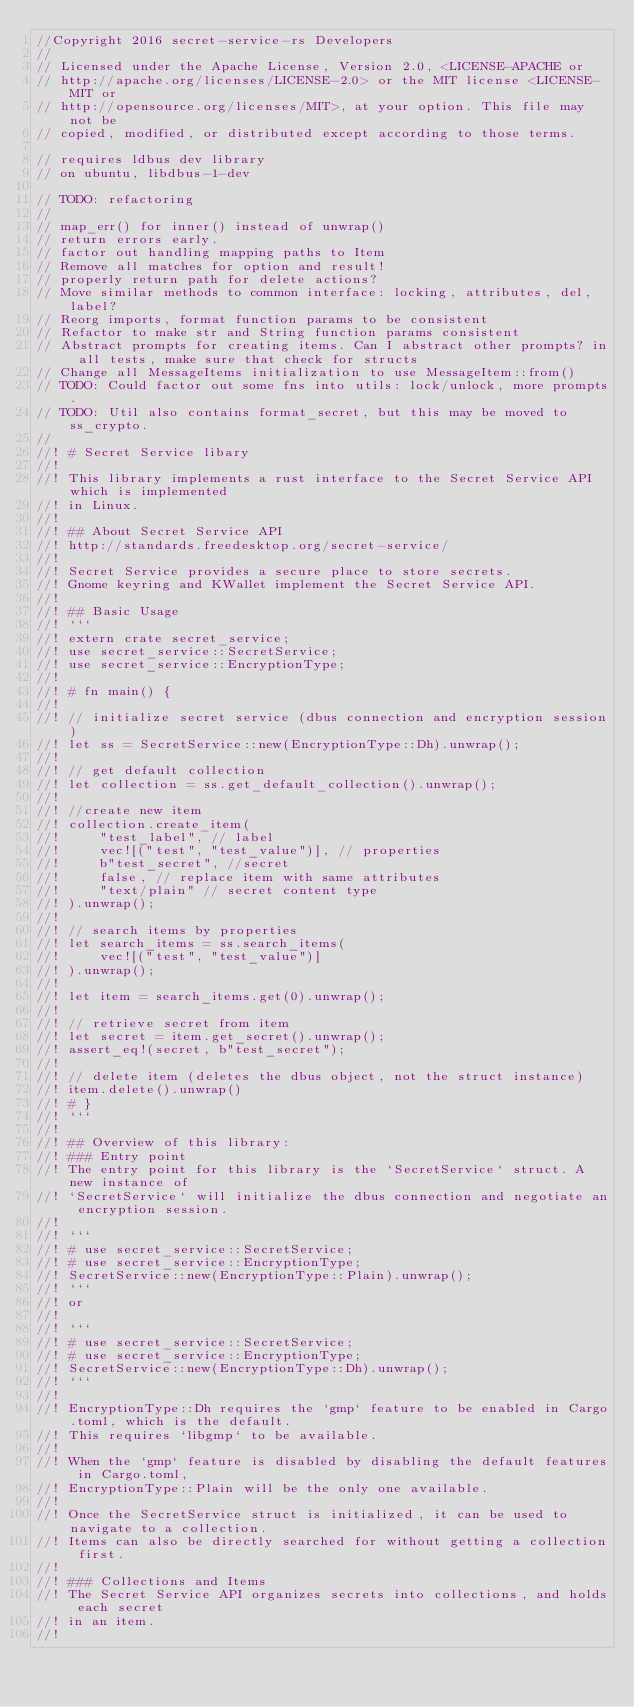Convert code to text. <code><loc_0><loc_0><loc_500><loc_500><_Rust_>//Copyright 2016 secret-service-rs Developers
//
// Licensed under the Apache License, Version 2.0, <LICENSE-APACHE or
// http://apache.org/licenses/LICENSE-2.0> or the MIT license <LICENSE-MIT or
// http://opensource.org/licenses/MIT>, at your option. This file may not be
// copied, modified, or distributed except according to those terms.

// requires ldbus dev library
// on ubuntu, libdbus-1-dev

// TODO: refactoring
//
// map_err() for inner() instead of unwrap()
// return errors early.
// factor out handling mapping paths to Item
// Remove all matches for option and result!
// properly return path for delete actions?
// Move similar methods to common interface: locking, attributes, del, label?
// Reorg imports, format function params to be consistent
// Refactor to make str and String function params consistent
// Abstract prompts for creating items. Can I abstract other prompts? in all tests, make sure that check for structs
// Change all MessageItems initialization to use MessageItem::from()
// TODO: Could factor out some fns into utils: lock/unlock, more prompts.
// TODO: Util also contains format_secret, but this may be moved to ss_crypto.
//
//! # Secret Service libary
//!
//! This library implements a rust interface to the Secret Service API which is implemented
//! in Linux.
//!
//! ## About Secret Service API
//! http://standards.freedesktop.org/secret-service/
//!
//! Secret Service provides a secure place to store secrets.
//! Gnome keyring and KWallet implement the Secret Service API.
//!
//! ## Basic Usage
//! ```
//! extern crate secret_service;
//! use secret_service::SecretService;
//! use secret_service::EncryptionType;
//!
//! # fn main() {
//!
//! // initialize secret service (dbus connection and encryption session)
//! let ss = SecretService::new(EncryptionType::Dh).unwrap();
//!
//! // get default collection
//! let collection = ss.get_default_collection().unwrap();
//!
//! //create new item
//! collection.create_item(
//!     "test_label", // label
//!     vec![("test", "test_value")], // properties
//!     b"test_secret", //secret
//!     false, // replace item with same attributes
//!     "text/plain" // secret content type
//! ).unwrap();
//!
//! // search items by properties
//! let search_items = ss.search_items(
//!     vec![("test", "test_value")]
//! ).unwrap();
//!
//! let item = search_items.get(0).unwrap();
//!
//! // retrieve secret from item
//! let secret = item.get_secret().unwrap();
//! assert_eq!(secret, b"test_secret");
//!
//! // delete item (deletes the dbus object, not the struct instance)
//! item.delete().unwrap()
//! # }
//! ```
//!
//! ## Overview of this library:
//! ### Entry point
//! The entry point for this library is the `SecretService` struct. A new instance of
//! `SecretService` will initialize the dbus connection and negotiate an encryption session.
//!
//! ```
//! # use secret_service::SecretService;
//! # use secret_service::EncryptionType;
//! SecretService::new(EncryptionType::Plain).unwrap();
//! ```
//! or
//!
//! ```
//! # use secret_service::SecretService;
//! # use secret_service::EncryptionType;
//! SecretService::new(EncryptionType::Dh).unwrap();
//! ```
//!
//! EncryptionType::Dh requires the `gmp` feature to be enabled in Cargo.toml, which is the default.
//! This requires `libgmp` to be available.
//!
//! When the `gmp` feature is disabled by disabling the default features in Cargo.toml,
//! EncryptionType::Plain will be the only one available.
//!
//! Once the SecretService struct is initialized, it can be used to navigate to a collection.
//! Items can also be directly searched for without getting a collection first.
//!
//! ### Collections and Items
//! The Secret Service API organizes secrets into collections, and holds each secret
//! in an item.
//!</code> 